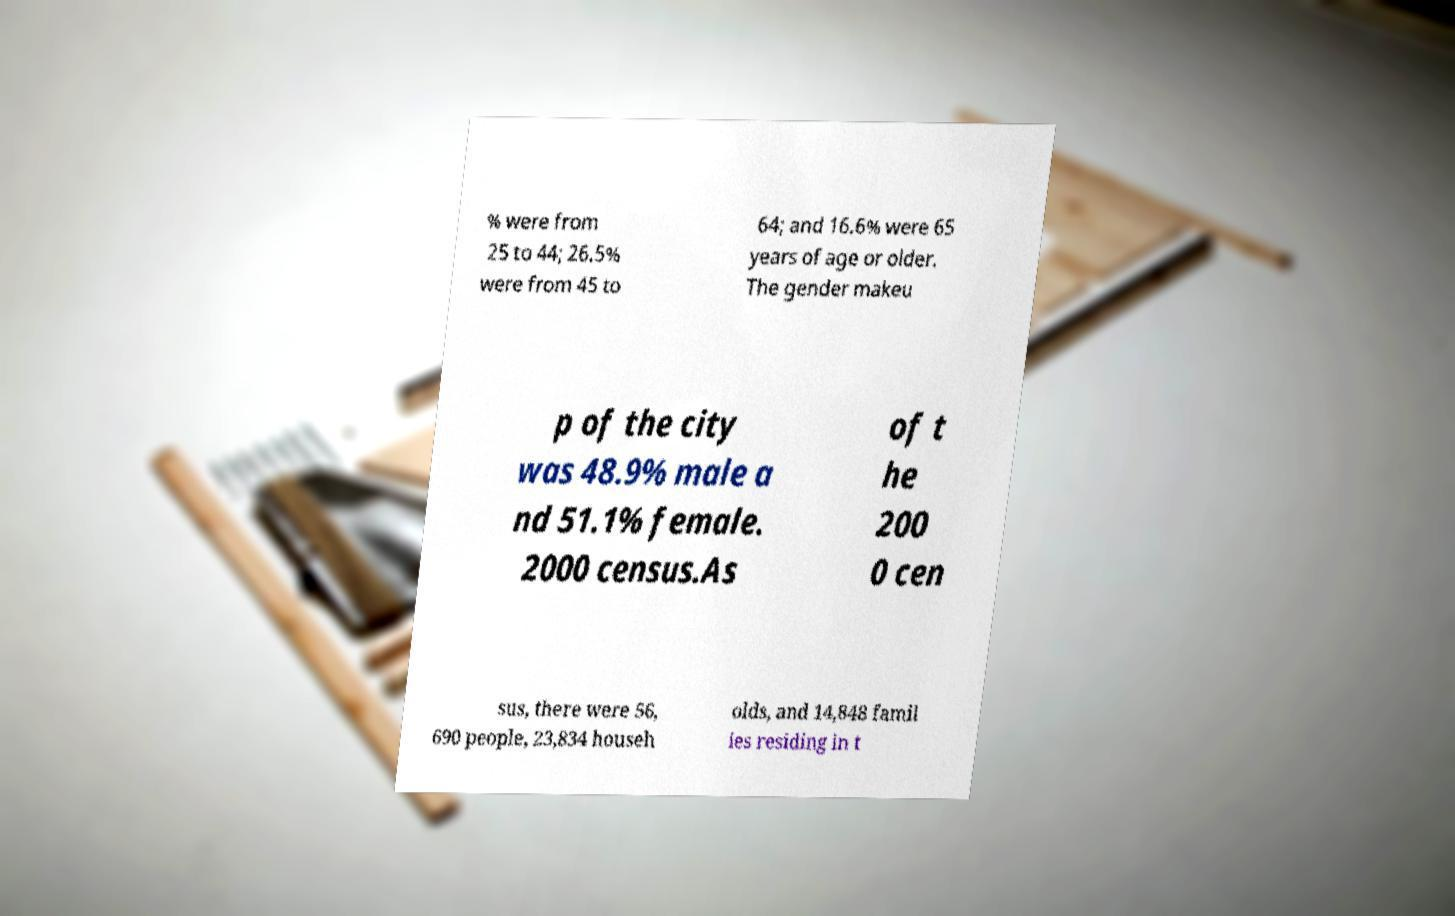I need the written content from this picture converted into text. Can you do that? % were from 25 to 44; 26.5% were from 45 to 64; and 16.6% were 65 years of age or older. The gender makeu p of the city was 48.9% male a nd 51.1% female. 2000 census.As of t he 200 0 cen sus, there were 56, 690 people, 23,834 househ olds, and 14,848 famil ies residing in t 